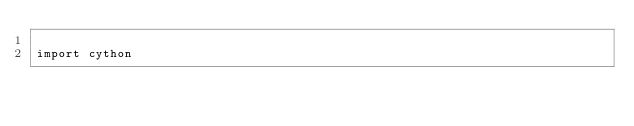<code> <loc_0><loc_0><loc_500><loc_500><_Cython_>
import cython


</code> 